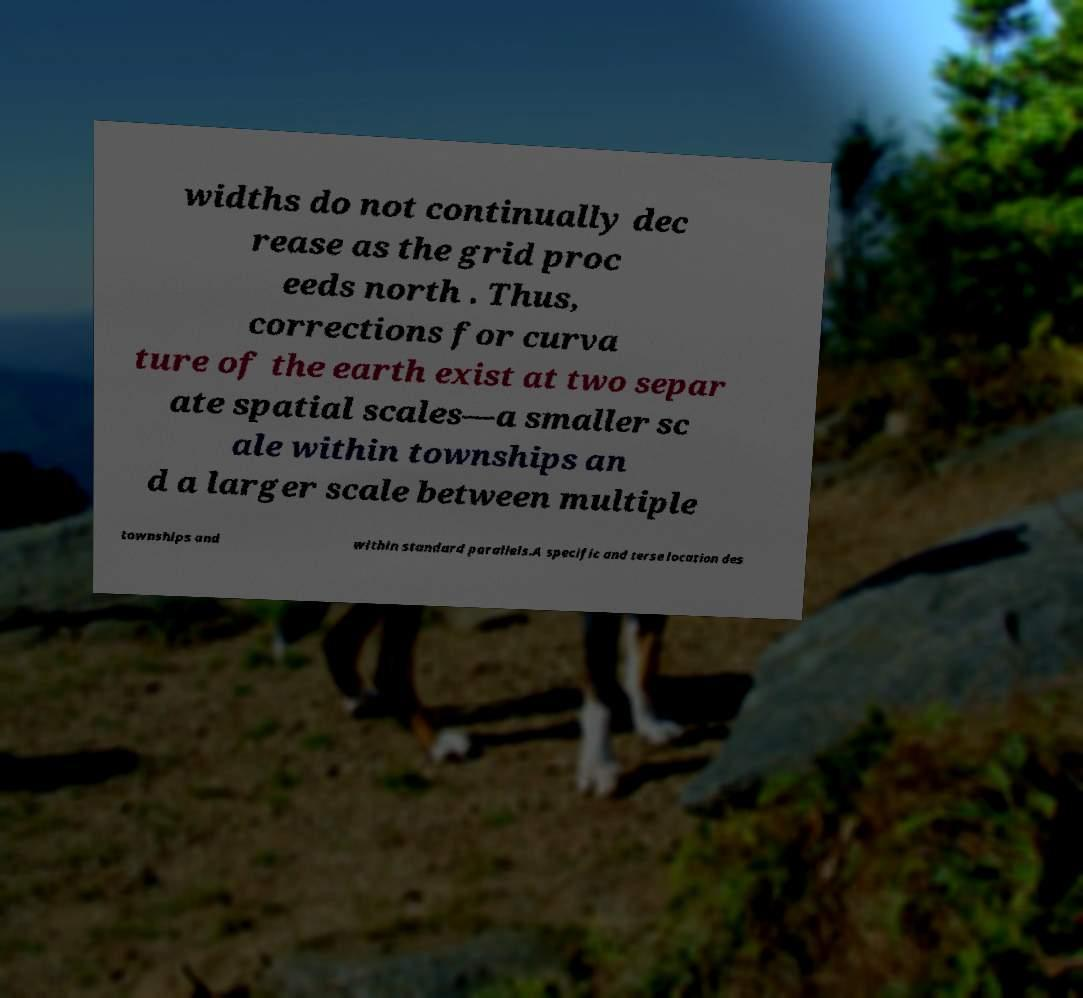I need the written content from this picture converted into text. Can you do that? widths do not continually dec rease as the grid proc eeds north . Thus, corrections for curva ture of the earth exist at two separ ate spatial scales—a smaller sc ale within townships an d a larger scale between multiple townships and within standard parallels.A specific and terse location des 